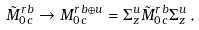Convert formula to latex. <formula><loc_0><loc_0><loc_500><loc_500>\tilde { M } _ { 0 \, c } ^ { r \, b } \rightarrow M _ { 0 \, c } ^ { r \, b \oplus u } = \Sigma _ { z } ^ { u } \tilde { M } _ { 0 \, c } ^ { r \, b } \Sigma _ { z } ^ { u } \, ,</formula> 